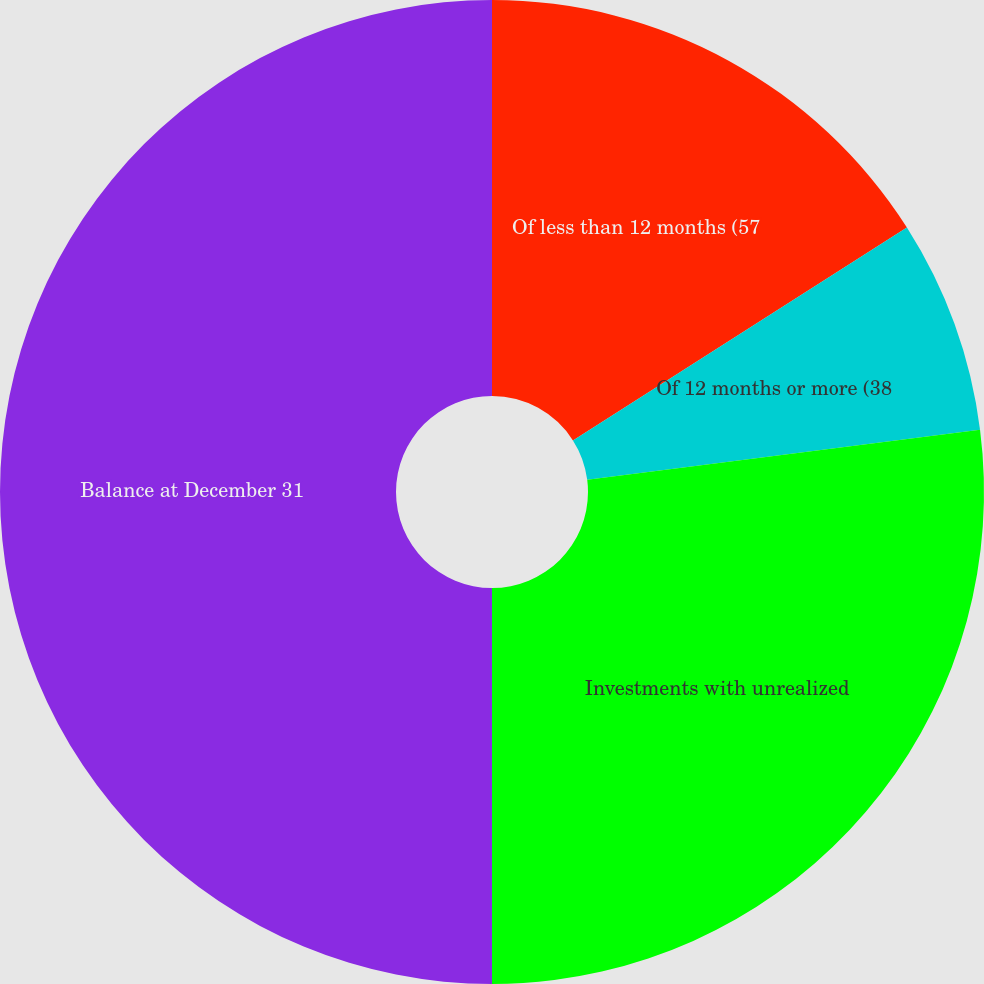Convert chart. <chart><loc_0><loc_0><loc_500><loc_500><pie_chart><fcel>Of less than 12 months (57<fcel>Of 12 months or more (38<fcel>Investments with unrealized<fcel>Balance at December 31<nl><fcel>15.97%<fcel>7.01%<fcel>27.02%<fcel>50.0%<nl></chart> 